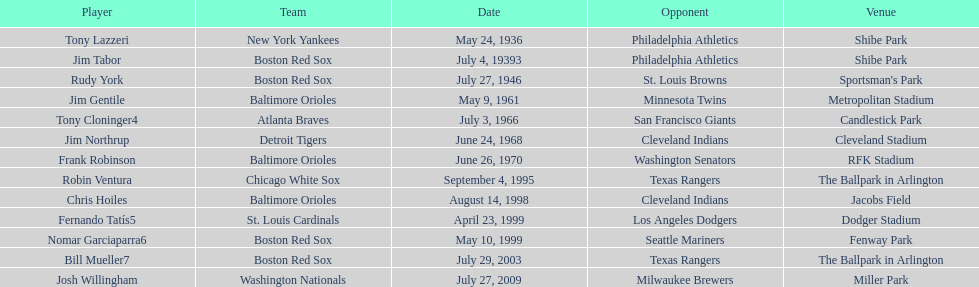What is the name of the most recent individual who has achieved this to date? Josh Willingham. 